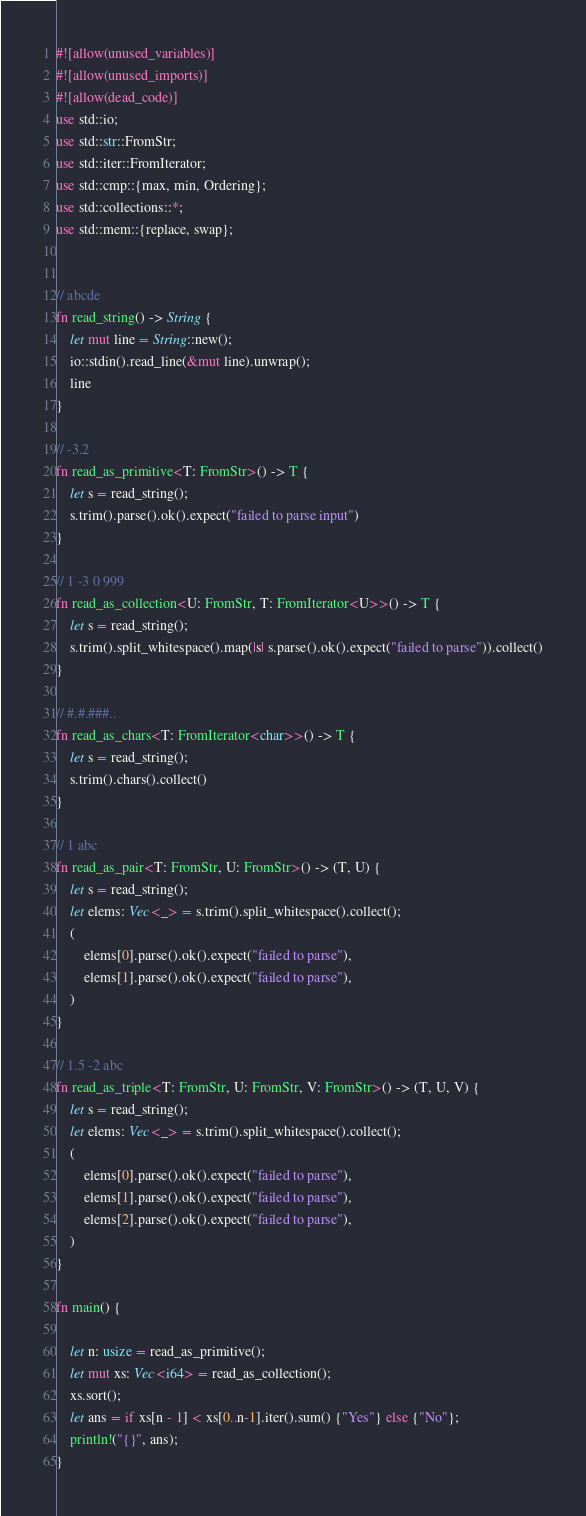<code> <loc_0><loc_0><loc_500><loc_500><_Rust_>#![allow(unused_variables)]
#![allow(unused_imports)]
#![allow(dead_code)]
use std::io;
use std::str::FromStr;
use std::iter::FromIterator;
use std::cmp::{max, min, Ordering};
use std::collections::*;
use std::mem::{replace, swap};


// abcde
fn read_string() -> String {
    let mut line = String::new();
    io::stdin().read_line(&mut line).unwrap();
    line
}

// -3.2
fn read_as_primitive<T: FromStr>() -> T {
    let s = read_string();
    s.trim().parse().ok().expect("failed to parse input")
}

// 1 -3 0 999
fn read_as_collection<U: FromStr, T: FromIterator<U>>() -> T {
    let s = read_string();
    s.trim().split_whitespace().map(|s| s.parse().ok().expect("failed to parse")).collect()
}

// #.#.###..
fn read_as_chars<T: FromIterator<char>>() -> T {
    let s = read_string();
    s.trim().chars().collect()
}

// 1 abc
fn read_as_pair<T: FromStr, U: FromStr>() -> (T, U) {
    let s = read_string();
    let elems: Vec<_> = s.trim().split_whitespace().collect();    
    (
        elems[0].parse().ok().expect("failed to parse"), 
        elems[1].parse().ok().expect("failed to parse"),
    )
}

// 1.5 -2 abc
fn read_as_triple<T: FromStr, U: FromStr, V: FromStr>() -> (T, U, V) {
    let s = read_string();
    let elems: Vec<_> = s.trim().split_whitespace().collect();
    (
        elems[0].parse().ok().expect("failed to parse"), 
        elems[1].parse().ok().expect("failed to parse"),
        elems[2].parse().ok().expect("failed to parse"),
    )
}

fn main() {

    let n: usize = read_as_primitive();
    let mut xs: Vec<i64> = read_as_collection();
    xs.sort();
    let ans = if xs[n - 1] < xs[0..n-1].iter().sum() {"Yes"} else {"No"};
    println!("{}", ans);
}</code> 